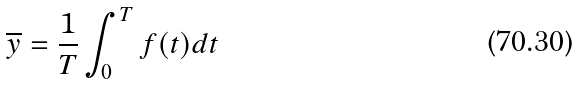Convert formula to latex. <formula><loc_0><loc_0><loc_500><loc_500>\overline { y } = \frac { 1 } { T } \int _ { 0 } ^ { T } f ( t ) d t</formula> 